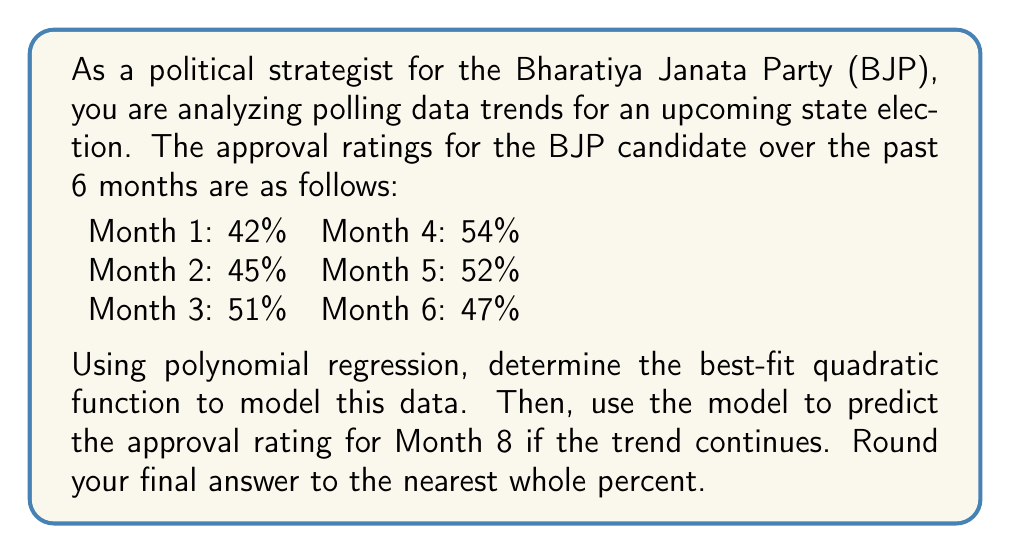Can you answer this question? To solve this problem, we'll use quadratic regression to find the best-fit polynomial of degree 2. Let's follow these steps:

1) Let x represent the month number (1-6) and y represent the approval rating.

2) We need to find a function of the form $y = ax^2 + bx + c$ that best fits the data.

3) To find the coefficients a, b, and c, we'll use a system of normal equations:

   $$\begin{cases}
   \sum y = an + b\sum x + c\sum x^2 \\
   \sum xy = a\sum x + b\sum x^2 + c\sum x^3 \\
   \sum x^2y = a\sum x^2 + b\sum x^3 + c\sum x^4
   \end{cases}$$

4) Calculate the required sums:
   
   $\sum x = 1 + 2 + 3 + 4 + 5 + 6 = 21$
   $\sum x^2 = 1 + 4 + 9 + 16 + 25 + 36 = 91$
   $\sum x^3 = 1 + 8 + 27 + 64 + 125 + 216 = 441$
   $\sum x^4 = 1 + 16 + 81 + 256 + 625 + 1296 = 2275$
   $\sum y = 42 + 45 + 51 + 54 + 52 + 47 = 291$
   $\sum xy = 42(1) + 45(2) + 51(3) + 54(4) + 52(5) + 47(6) = 1089$
   $\sum x^2y = 42(1) + 45(4) + 51(9) + 54(16) + 52(25) + 47(36) = 4369$

5) Substitute these values into the system of equations:

   $$\begin{cases}
   291 = 6a + 21b + 91c \\
   1089 = 21a + 91b + 441c \\
   4369 = 91a + 441b + 2275c
   \end{cases}$$

6) Solve this system of equations (using a calculator or computer algebra system) to get:

   $a \approx -1.2857$
   $b \approx 11.6429$
   $c \approx 31.9286$

7) Therefore, the quadratic function that best fits the data is:

   $y = -1.2857x^2 + 11.6429x + 31.9286$

8) To predict the approval rating for Month 8, substitute x = 8 into this equation:

   $y = -1.2857(8)^2 + 11.6429(8) + 31.9286$
   $y = -82.2848 + 93.1432 + 31.9286$
   $y = 42.787$

9) Rounding to the nearest whole percent, we get 43%.
Answer: 43% 